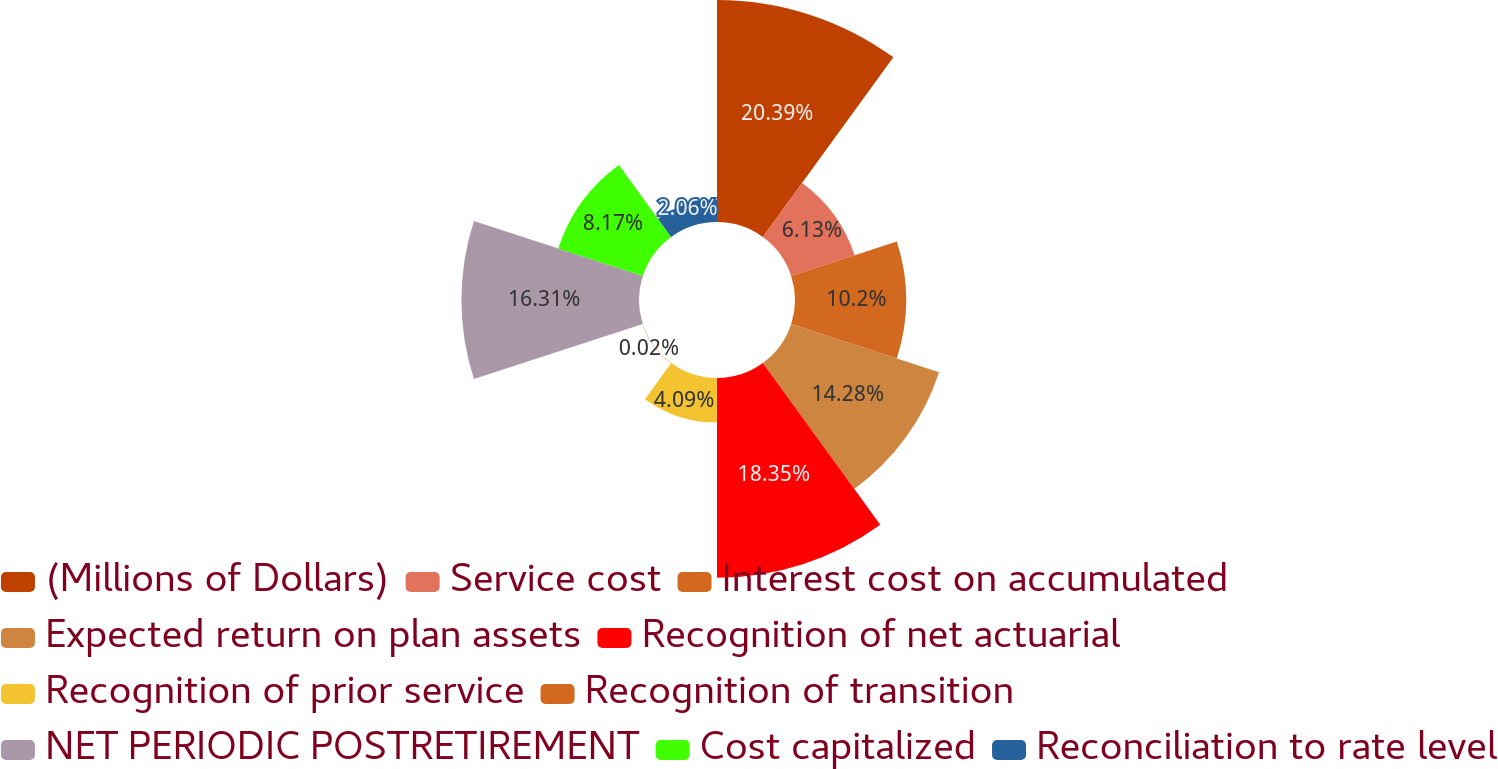<chart> <loc_0><loc_0><loc_500><loc_500><pie_chart><fcel>(Millions of Dollars)<fcel>Service cost<fcel>Interest cost on accumulated<fcel>Expected return on plan assets<fcel>Recognition of net actuarial<fcel>Recognition of prior service<fcel>Recognition of transition<fcel>NET PERIODIC POSTRETIREMENT<fcel>Cost capitalized<fcel>Reconciliation to rate level<nl><fcel>20.39%<fcel>6.13%<fcel>10.2%<fcel>14.28%<fcel>18.35%<fcel>4.09%<fcel>0.02%<fcel>16.31%<fcel>8.17%<fcel>2.06%<nl></chart> 